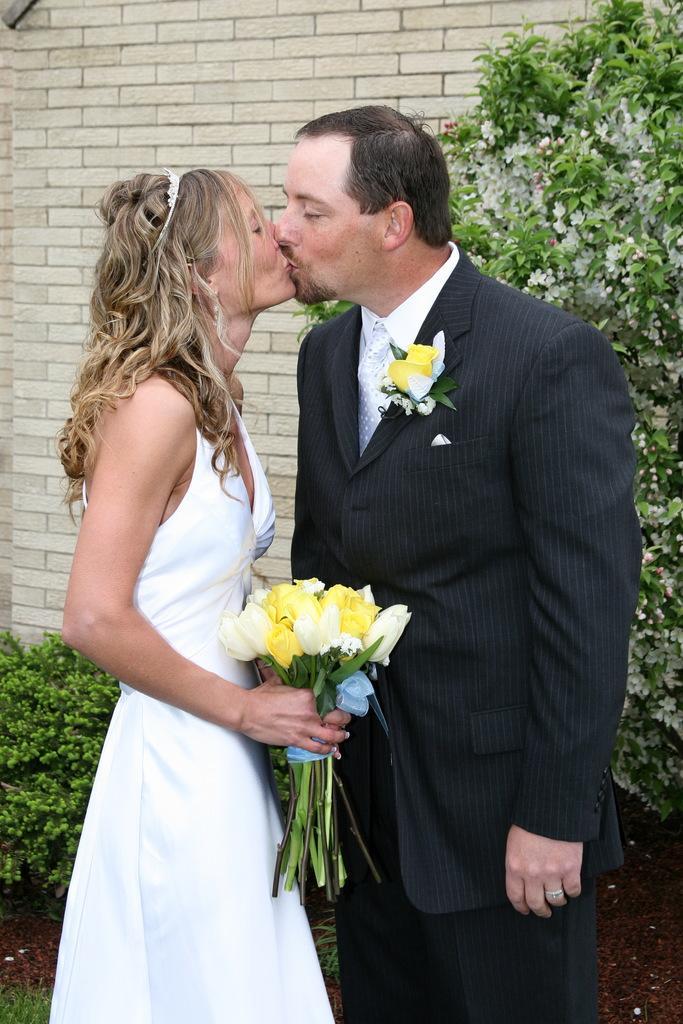Please provide a concise description of this image. In the picture we can see a man and a woman are standing and kissing and the woman is wearing a white dress and holding flowers and the man is wearing a black blazer with shirt and in the background we can see a house wall and some plants near it. 